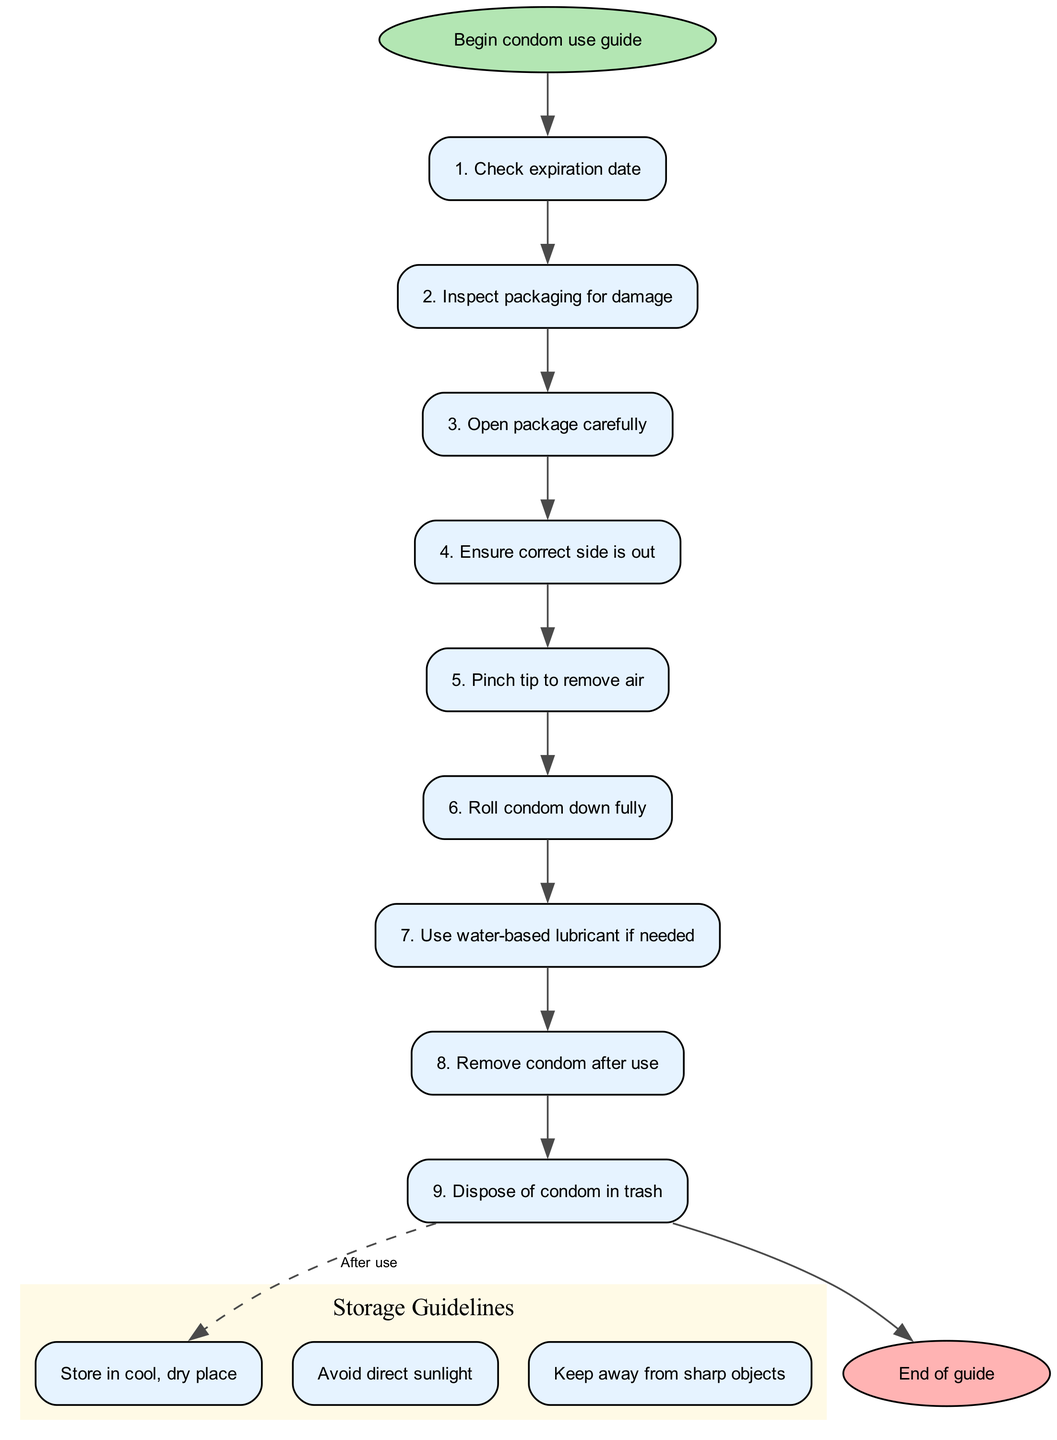What is the first step in the condom use guide? The first step in the diagram is "Check expiration date," as it is the starting point for the instructions on condom use.
Answer: Check expiration date How many steps are there in the condom use process? There are nine steps in the condom use process as outlined in the diagram.
Answer: 9 What should you do after rolling the condom down fully? After rolling the condom down fully, the next step is "Use water-based lubricant if needed," according to the flow of the instructions.
Answer: Use water-based lubricant if needed What is the last step before disposing of the condom? The last step before disposing of the condom is "Remove condom after use," which comes directly before the disposal instruction in the process.
Answer: Remove condom after use How many storage guidelines are provided in the diagram? The diagram provides three storage guidelines related to proper storage of condoms.
Answer: 3 What is the connection type between the last step of condom use and the storage guidelines? The connection type is dashed, indicating that the storage guidelines follow as a separate topic or a follow-up after completing the condom use steps.
Answer: Dashed Which storage guideline advises against exposing condoms to sunlight? The guideline that advises against exposing condoms to sunlight is "Avoid direct sunlight" as specified in the storage instructions.
Answer: Avoid direct sunlight Is there a step indicating the need to inspect the packaging? Yes, there is a step that specifically states "Inspect packaging for damage," which is the second step in the instruction flow.
Answer: Inspect packaging for damage 